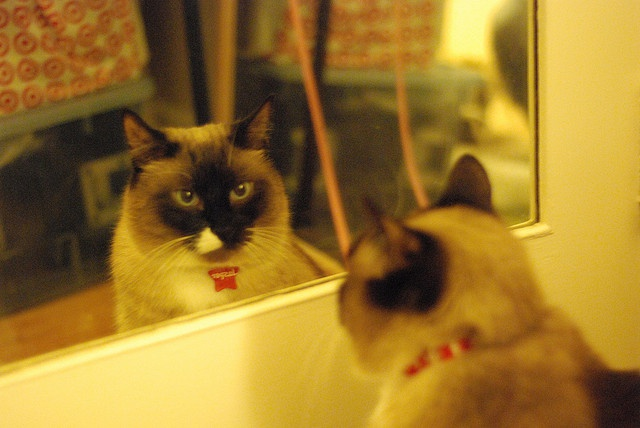Describe the objects in this image and their specific colors. I can see cat in brown, olive, black, orange, and maroon tones and cat in brown, black, orange, olive, and maroon tones in this image. 